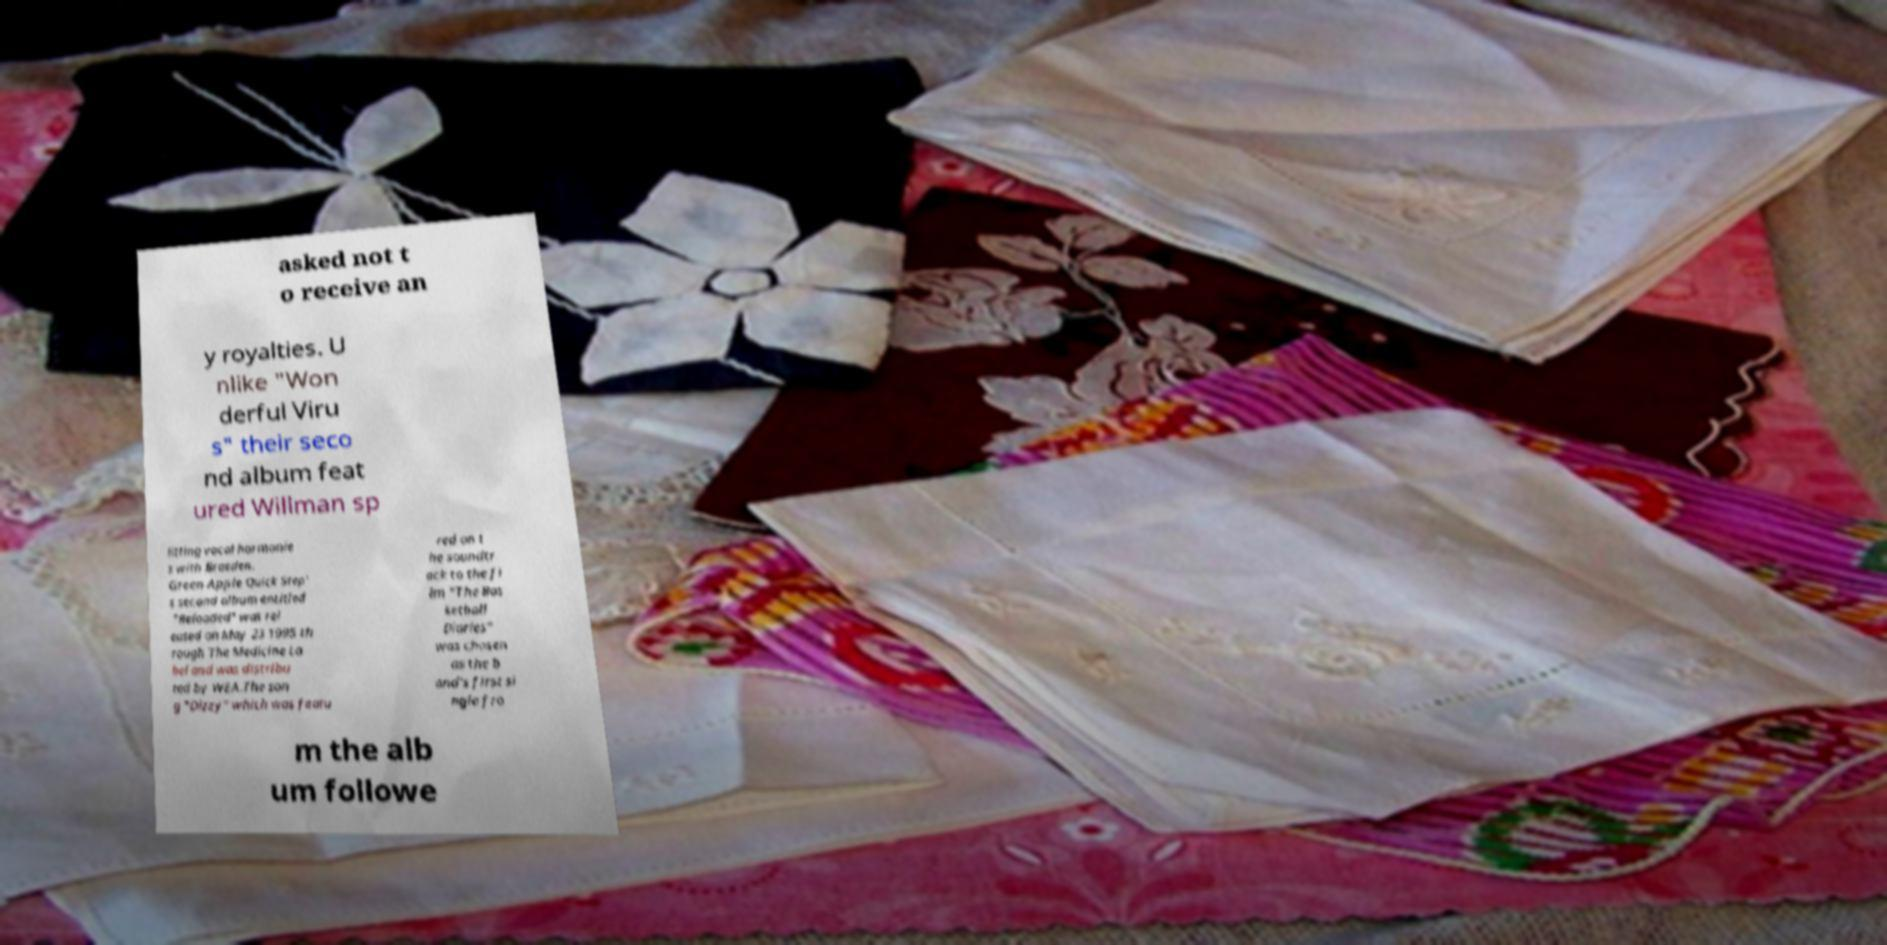Can you accurately transcribe the text from the provided image for me? asked not t o receive an y royalties. U nlike "Won derful Viru s" their seco nd album feat ured Willman sp litting vocal harmonie s with Braeden. Green Apple Quick Step' s second album entitled "Reloaded" was rel eased on May 23 1995 th rough The Medicine La bel and was distribu ted by WEA.The son g "Dizzy" which was featu red on t he soundtr ack to the fi lm "The Bas ketball Diaries" was chosen as the b and's first si ngle fro m the alb um followe 